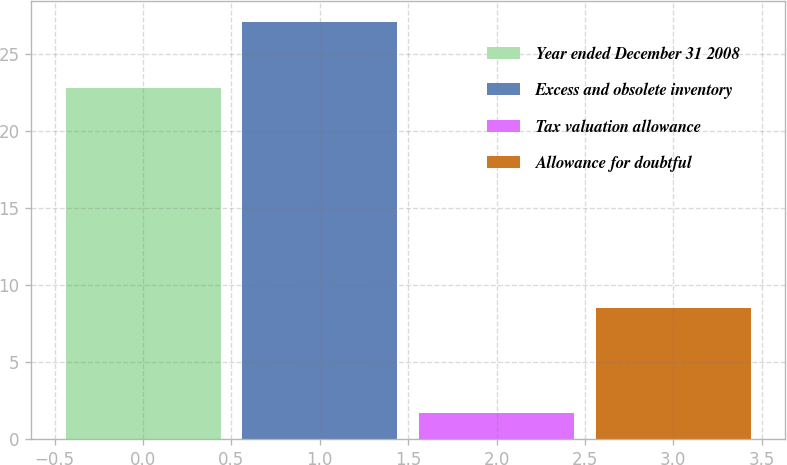<chart> <loc_0><loc_0><loc_500><loc_500><bar_chart><fcel>Year ended December 31 2008<fcel>Excess and obsolete inventory<fcel>Tax valuation allowance<fcel>Allowance for doubtful<nl><fcel>22.8<fcel>27.1<fcel>1.7<fcel>8.5<nl></chart> 